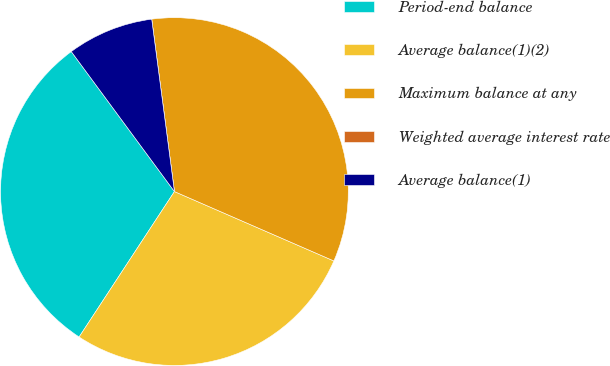Convert chart. <chart><loc_0><loc_0><loc_500><loc_500><pie_chart><fcel>Period-end balance<fcel>Average balance(1)(2)<fcel>Maximum balance at any<fcel>Weighted average interest rate<fcel>Average balance(1)<nl><fcel>30.66%<fcel>27.7%<fcel>33.62%<fcel>0.0%<fcel>8.02%<nl></chart> 